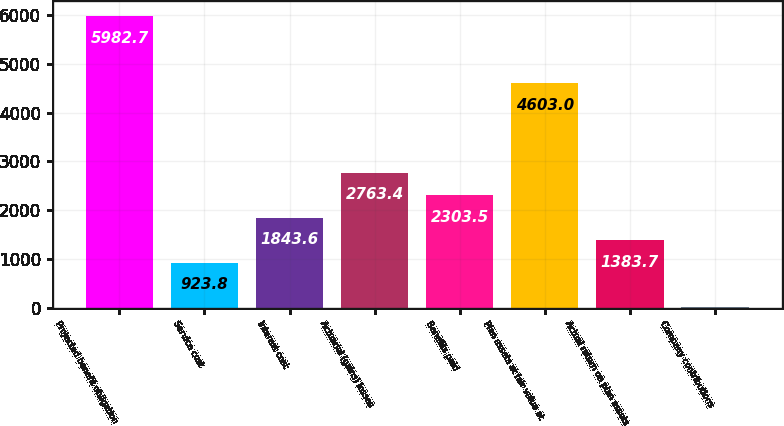Convert chart to OTSL. <chart><loc_0><loc_0><loc_500><loc_500><bar_chart><fcel>Projected benefit obligation<fcel>Service cost<fcel>Interest cost<fcel>Actuarial (gains) losses<fcel>Benefits paid<fcel>Plan assets at fair value at<fcel>Actual return on plan assets<fcel>Company contributions<nl><fcel>5982.7<fcel>923.8<fcel>1843.6<fcel>2763.4<fcel>2303.5<fcel>4603<fcel>1383.7<fcel>4<nl></chart> 